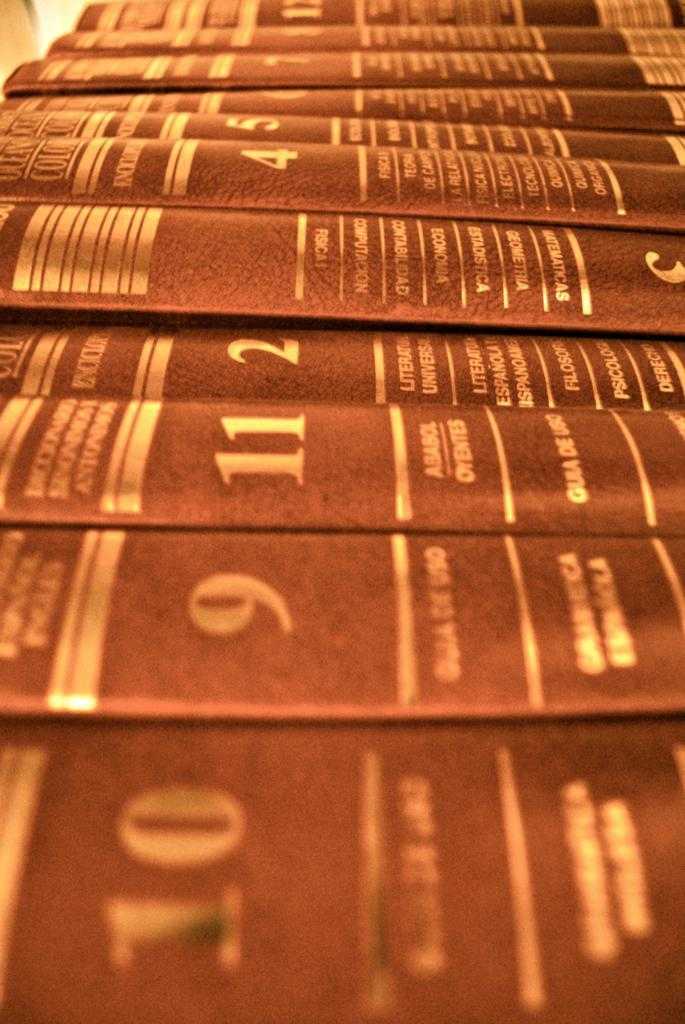<image>
Give a short and clear explanation of the subsequent image. A blurred and coloured image of a group of of encyclopedias seen sideways on. 